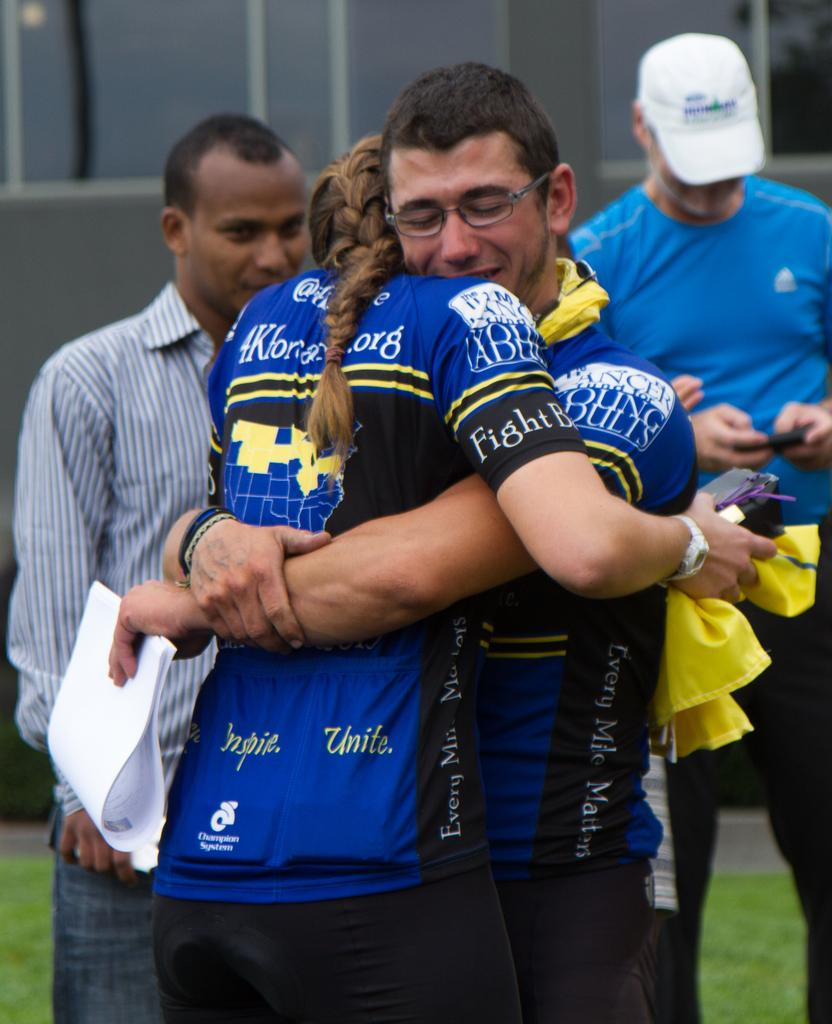<image>
Create a compact narrative representing the image presented. A woman with "inspire" and "unite" on the bottom of her shirt gives a hug. 